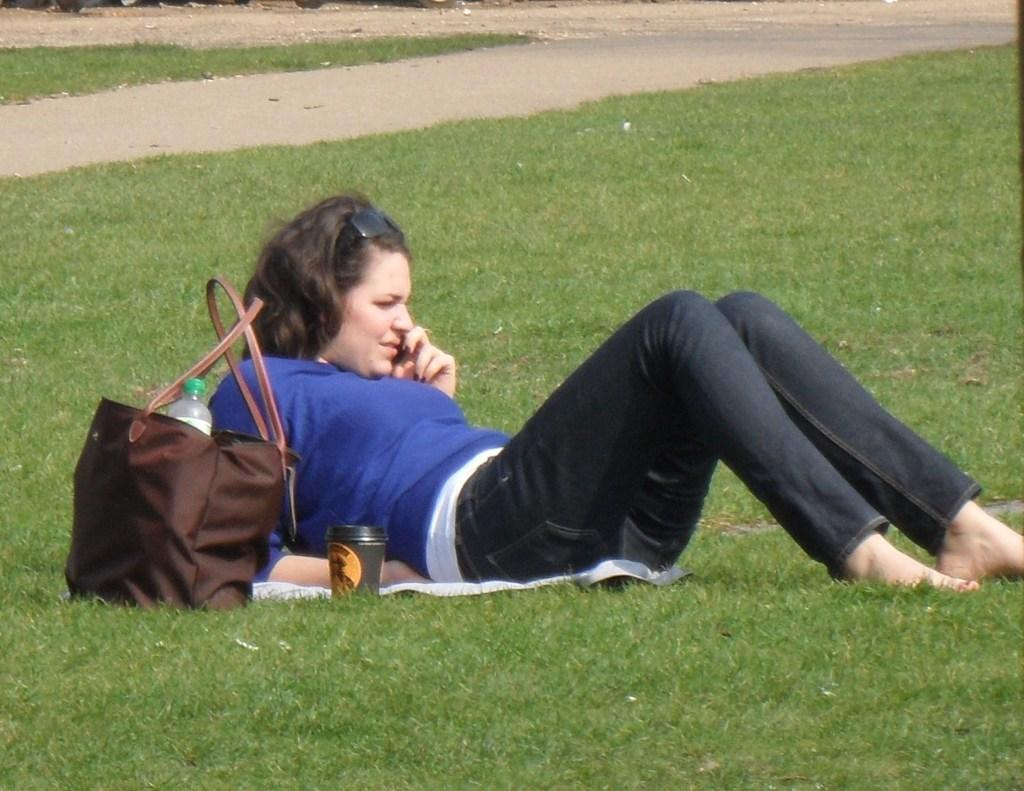What is the girl in the image doing? The girl is sitting on the grass in the image. What objects can be seen in the image besides the girl? There is a bag, a bottle, and a cup in the image. Can you see any cherries growing on the stove in the image? There is no stove or cherries present in the image. 